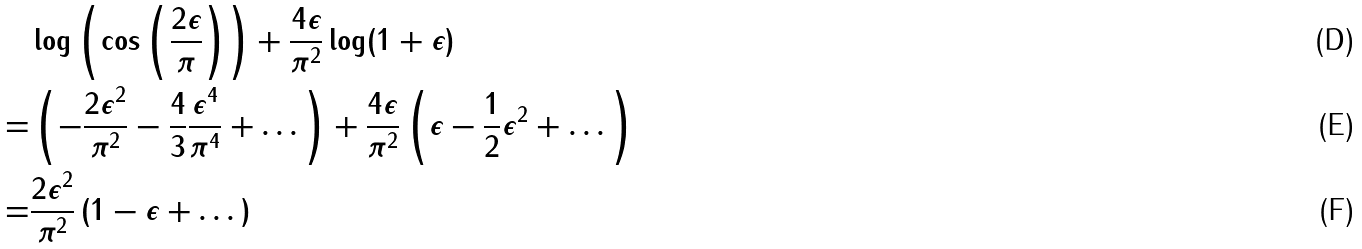<formula> <loc_0><loc_0><loc_500><loc_500>& \log \left ( \cos \left ( \frac { 2 \epsilon } { \pi } \right ) \right ) + \frac { 4 \epsilon } { \pi ^ { 2 } } \log ( 1 + \epsilon ) \\ = & \left ( - \frac { 2 \epsilon ^ { 2 } } { \pi ^ { 2 } } - \frac { 4 } { 3 } \frac { \epsilon ^ { 4 } } { \pi ^ { 4 } } + \dots \right ) + \frac { 4 \epsilon } { \pi ^ { 2 } } \left ( \epsilon - \frac { 1 } { 2 } \epsilon ^ { 2 } + \dots \right ) \\ = & \frac { 2 \epsilon ^ { 2 } } { \pi ^ { 2 } } \left ( 1 - \epsilon + \dots \right )</formula> 